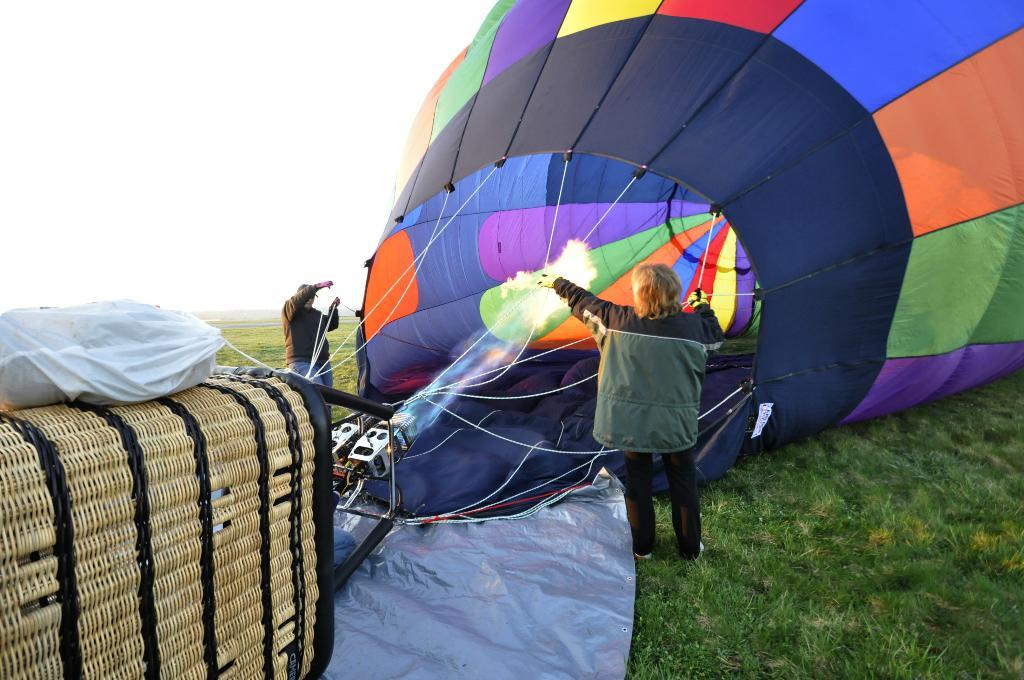How many people are in the image? There are two people in the image, a man and a woman. What are the man and woman doing in the image? They are standing on the ground and holding the ropes of a hot air balloon. What type of terrain is visible in the image? There is grass visible in the image. What object can be seen near the man and woman? There is a bag in the image. What is the condition of the sky in the image? The sky is visible in the image and appears cloudy. What type of shop can be seen in the background of the image? There is no shop visible in the image; it features a man, a woman, a hot air balloon, grass, a bag, and a cloudy sky. What color is the box that the man and woman are standing on in the image? There is no box present in the image; they are standing on the ground. 